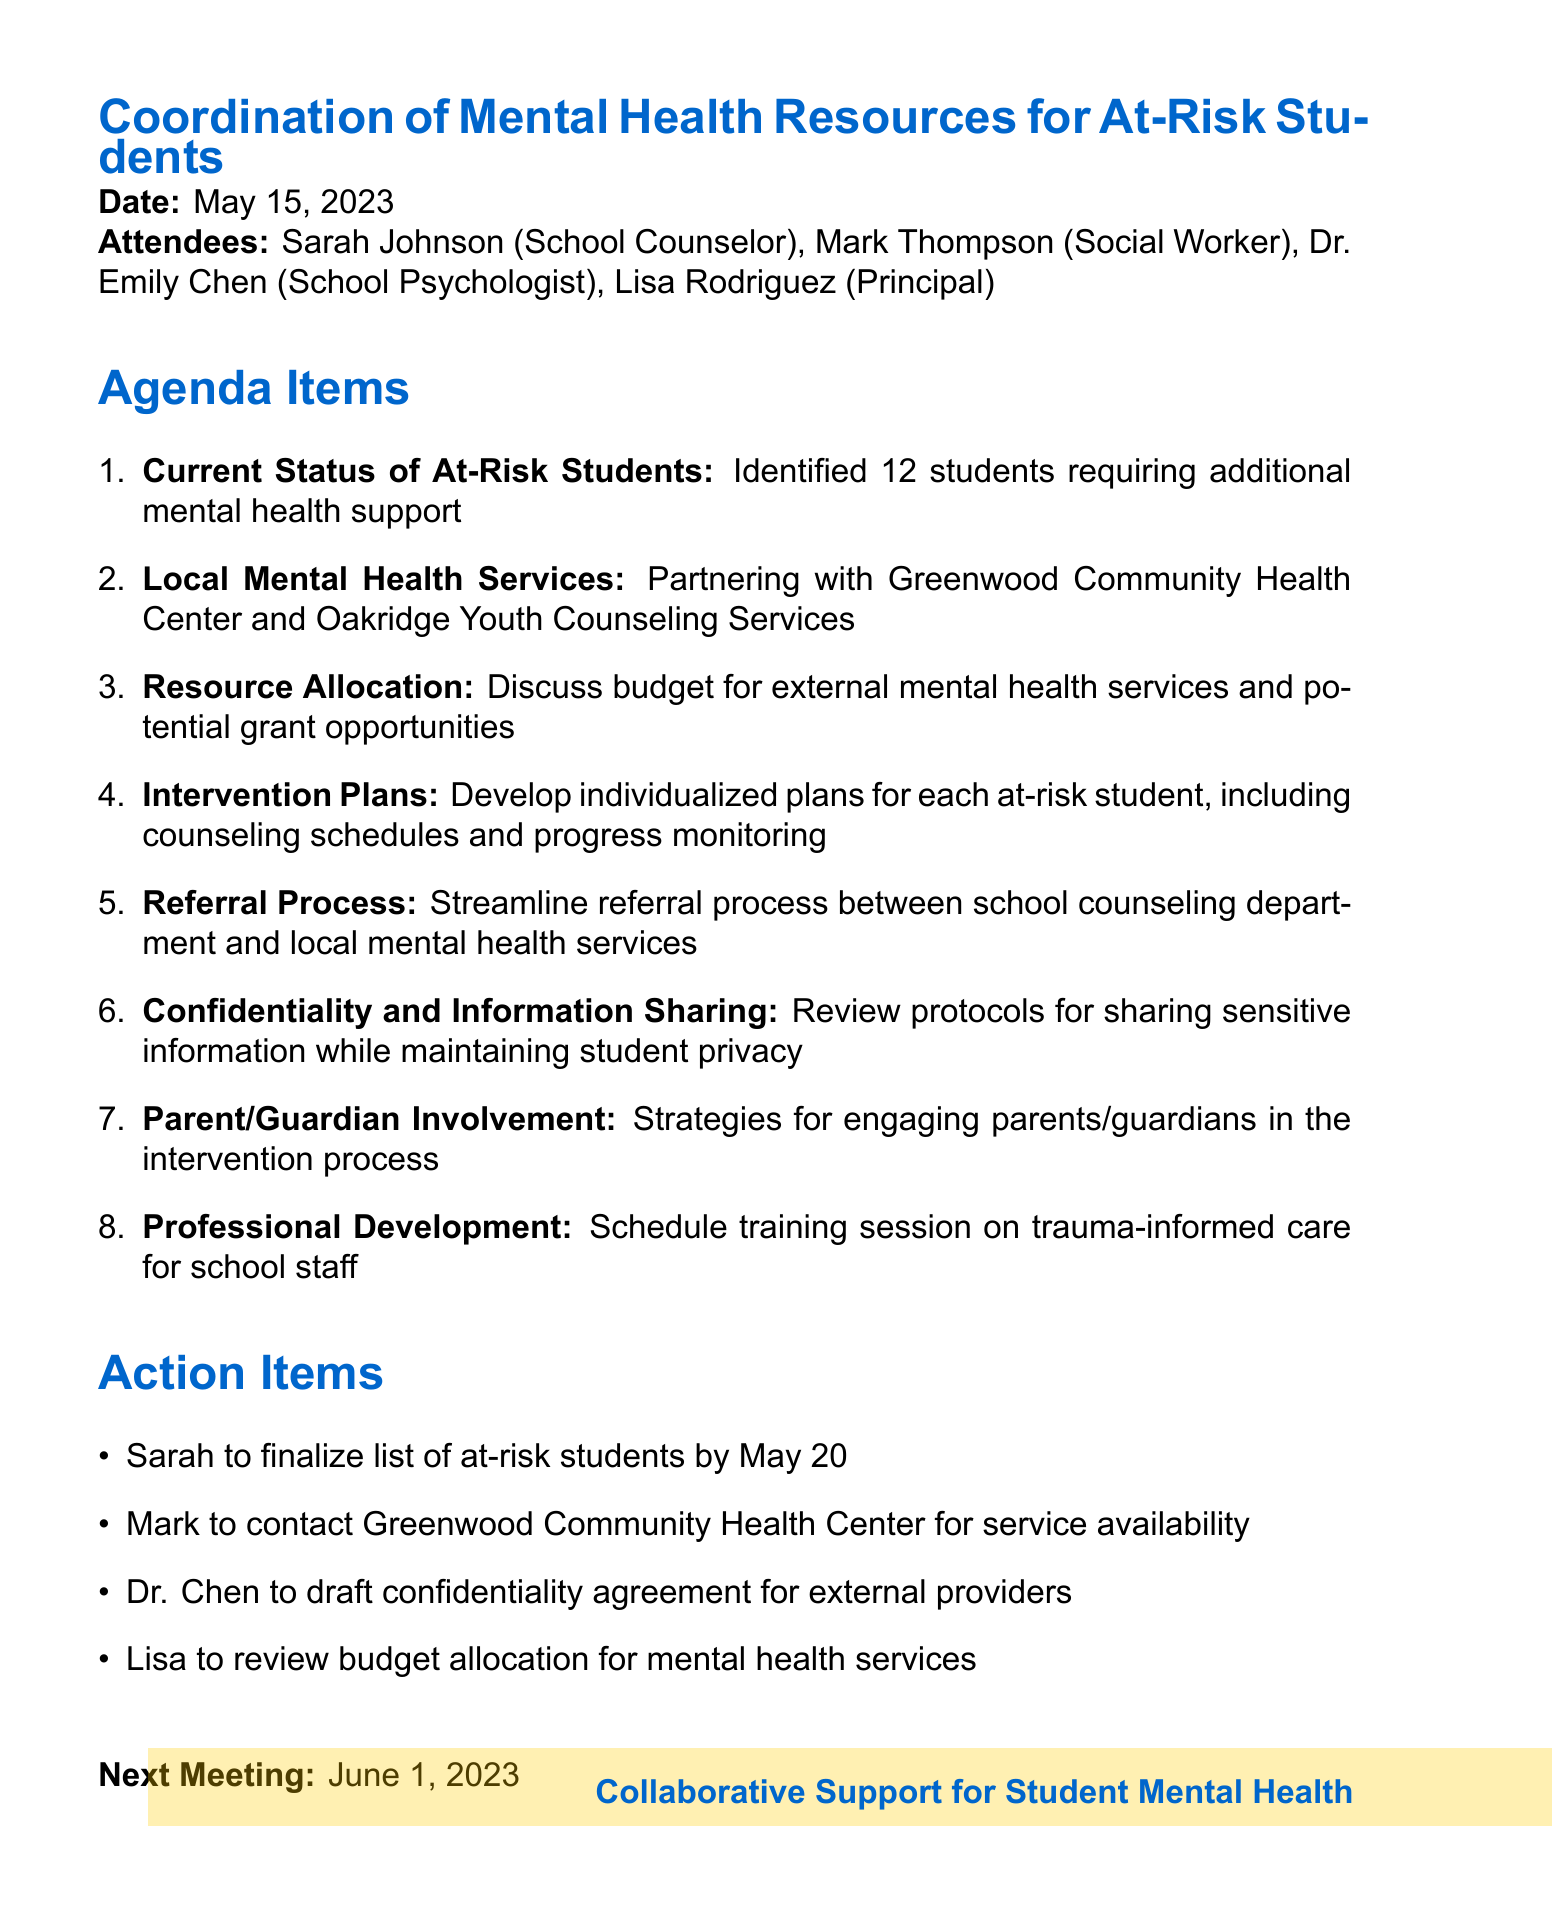what is the meeting date? The meeting date is explicitly stated in the document.
Answer: May 15, 2023 how many at-risk students were identified? The document mentions that 12 students require additional support.
Answer: 12 who is the school psychologist? The name of the school psychologist is listed among the attendees.
Answer: Dr. Emily Chen what is the next meeting date? The next meeting date is mentioned at the end of the document.
Answer: June 1, 2023 which local health center is partnering with the school? The document explicitly lists the partnered local health services.
Answer: Greenwood Community Health Center what is one of the action items assigned to Mark? The action items list specific tasks for each attendee.
Answer: contact Greenwood Community Health Center for service availability why is confidentiality important in the context of the meeting? The agenda item addresses the need for privacy protocols.
Answer: to maintain student privacy what type of training session was scheduled? The document lists a specific type of professional development.
Answer: trauma-informed care what is one strategy mentioned for involving parents/guardians? The agenda item refers to strategies for parent involvement in interventions.
Answer: engaging parents/guardians in the intervention process 